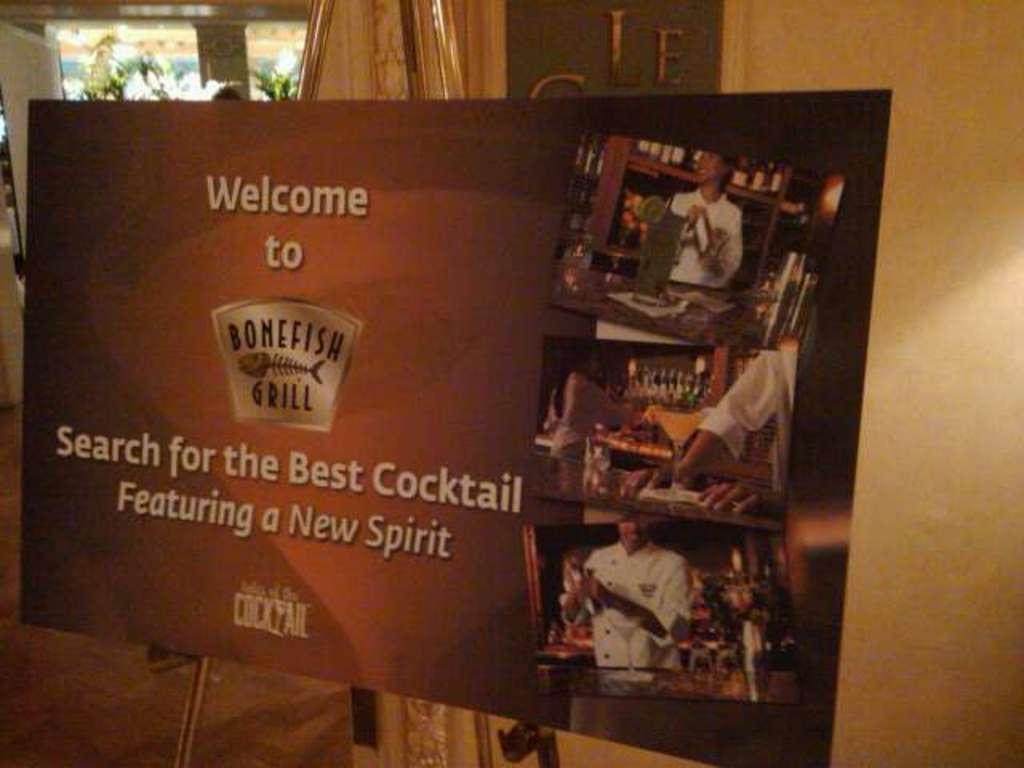Could you give a brief overview of what you see in this image? In this picture there is a board in the foreground and there is text and there are pictures of three people and objects on the board. At the back there are plants and there is text on the wall and there might be curtain. At the bottom there is a floor. 